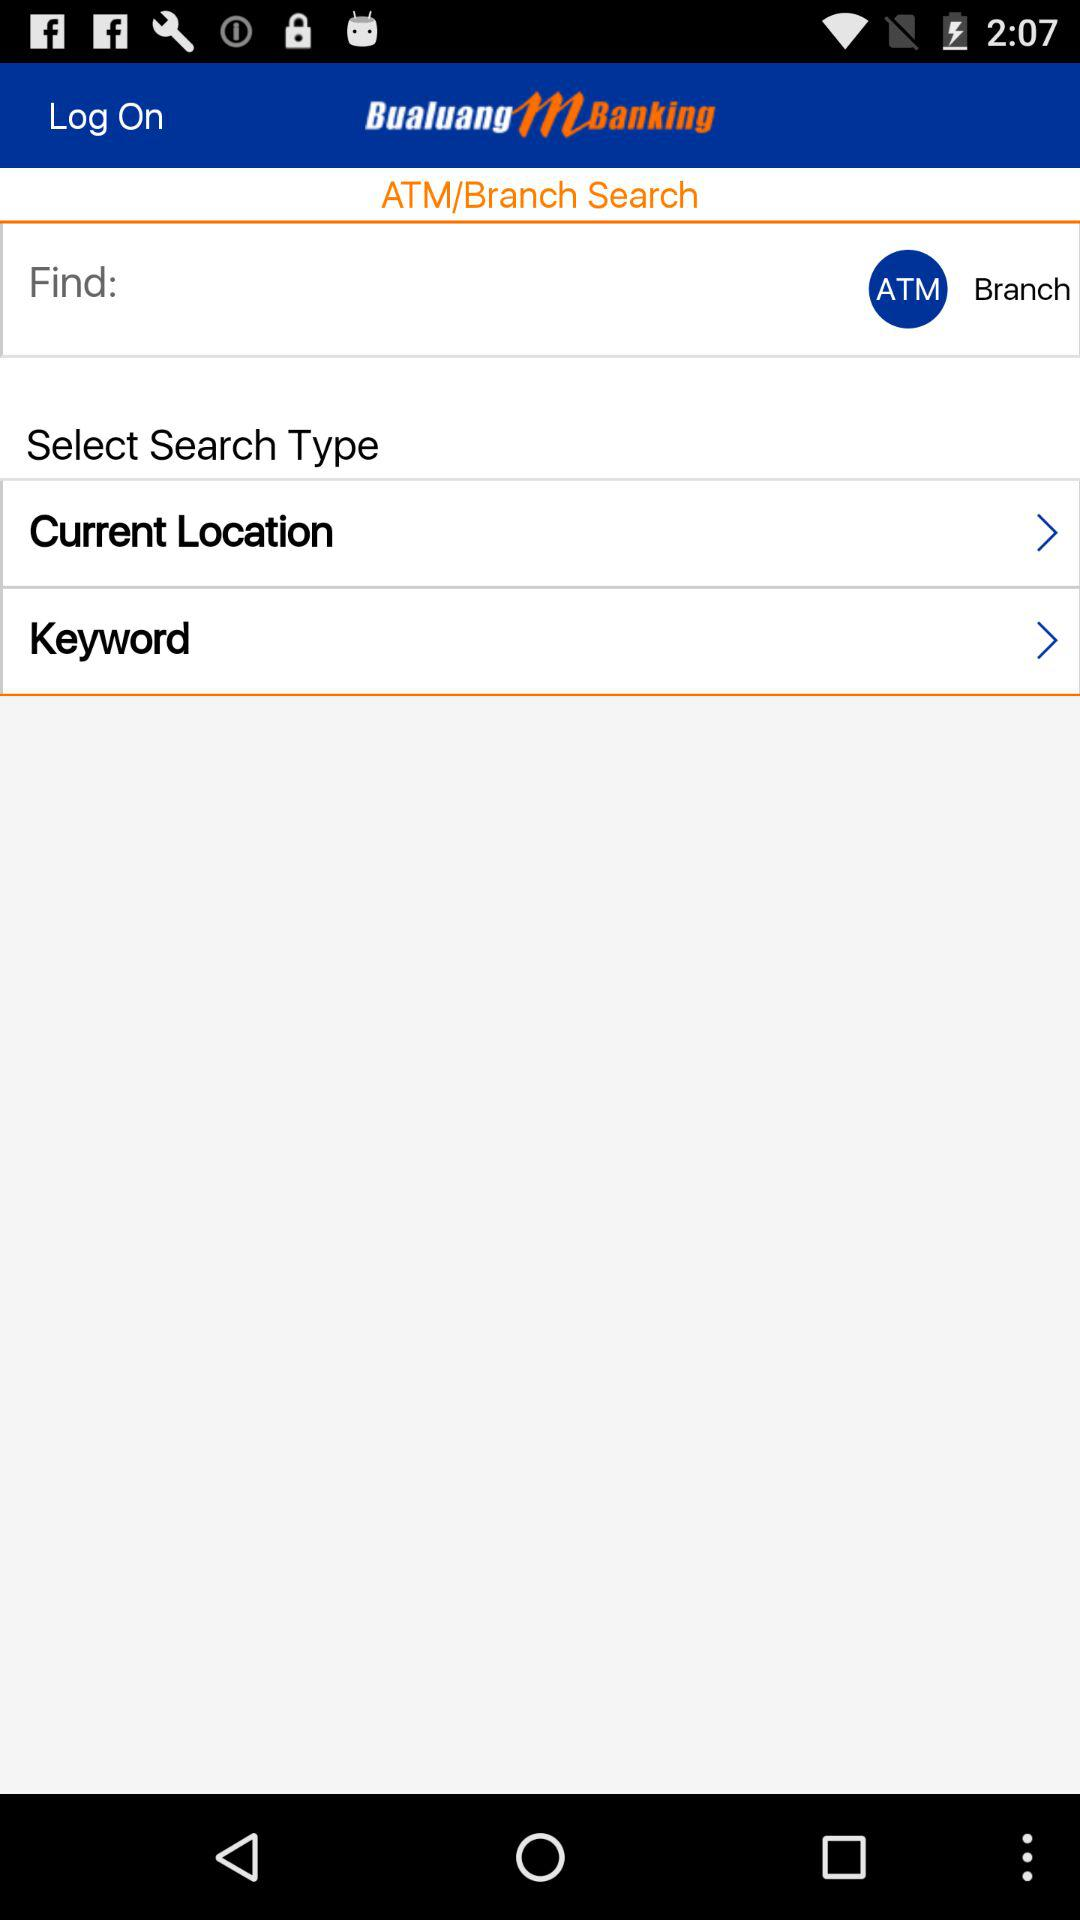What is the application name? The application name is "Bualuang mBanking". 